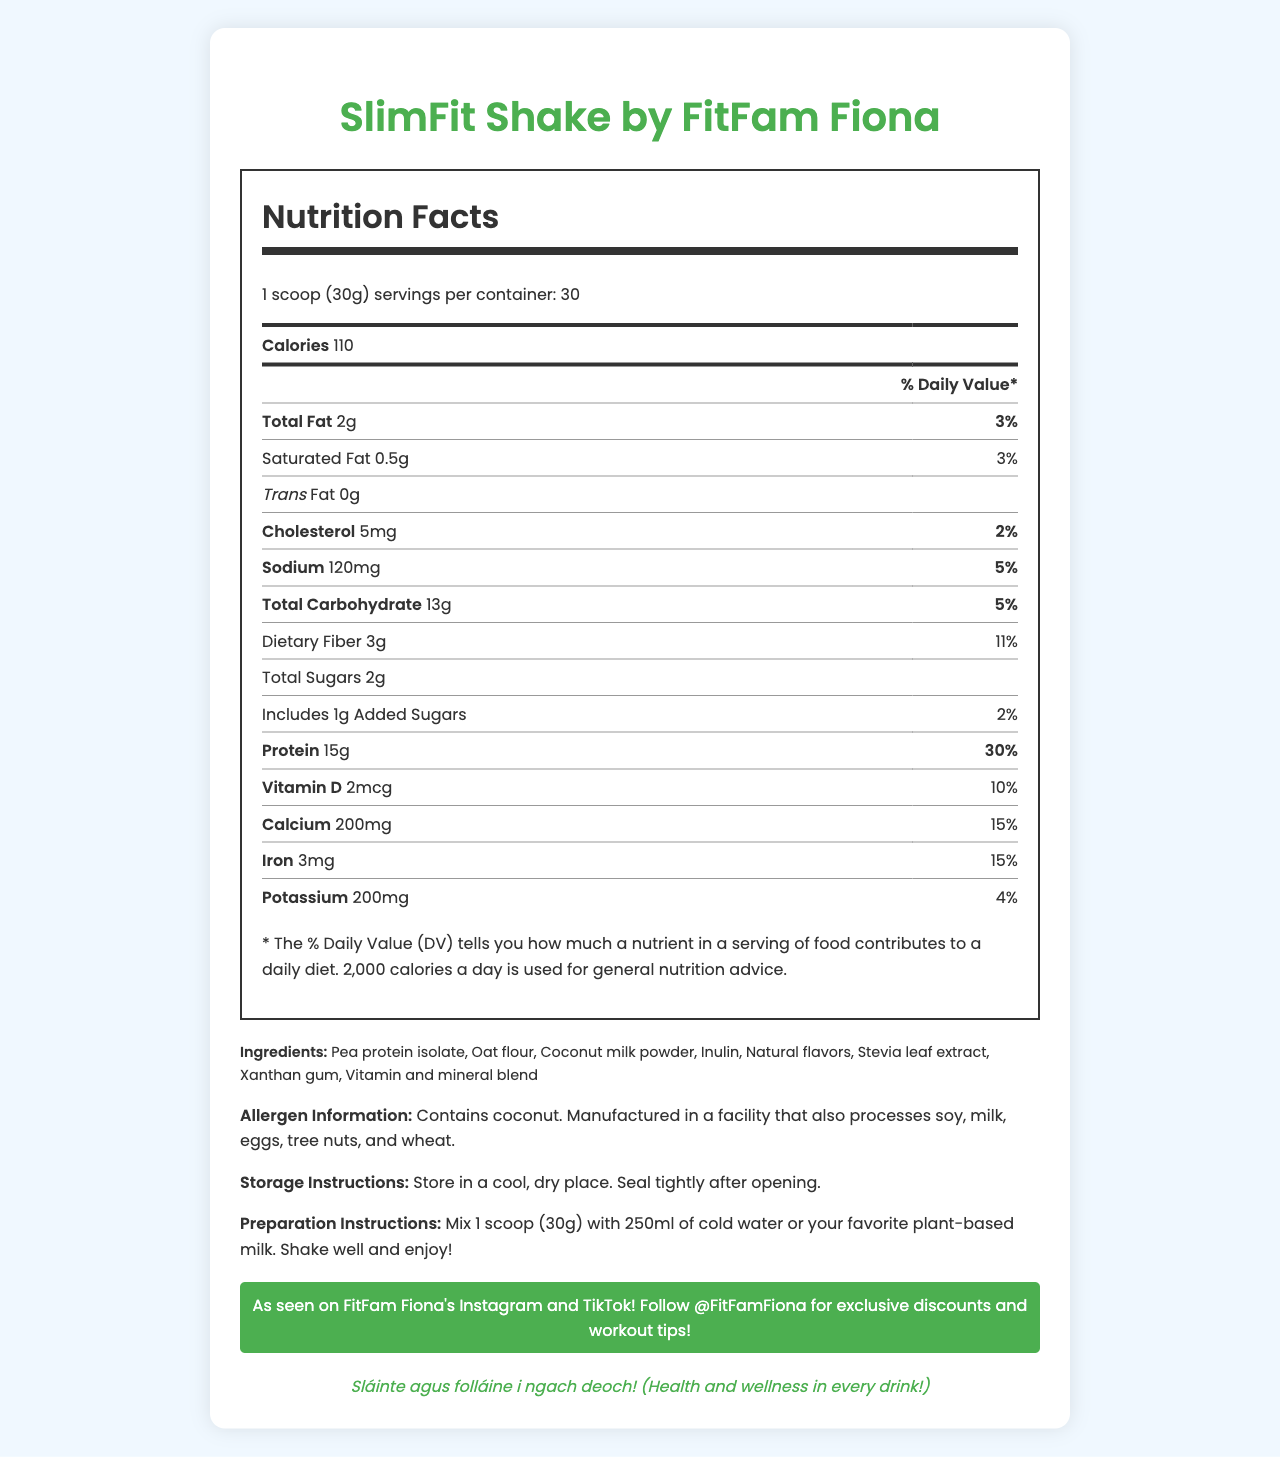what is the serving size of SlimFit Shake by FitFam Fiona? The document specifies the serving size as "1 scoop (30g)".
Answer: 1 scoop (30g) how many servings are there in a container of SlimFit Shake by FitFam Fiona? The document states that there are 30 servings per container.
Answer: 30 what is the total fat content per serving? The total fat per serving is listed as 2g.
Answer: 2g how many grams of dietary fiber are in each serving? The dietary fiber per serving is 3g as mentioned in the document.
Answer: 3g what is the suggested preparation method for SlimFit Shake by FitFam Fiona? The preparation instructions in the document elaborate on mixing 1 scoop (30g) with 250ml of cold water or plant-based milk and shaking it well.
Answer: Mix 1 scoop (30g) with 250ml of cold water or your favorite plant-based milk. Shake well and enjoy! how much cholesterol is there in one serving? A. 5mg B. 10mg C. 15mg D. 20mg The cholesterol content per serving is 5mg according to the document.
Answer: A. 5mg what is the daily value percentage of calcium in a single serving? A. 10% B. 15% C. 20% D. 25% The daily value percentage of calcium in a single serving is 15%.
Answer: B. 15% is the SlimFit Shake suitable for someone allergic to coconut? The allergen information states that the product contains coconut.
Answer: No describe the endorsement from FitFam Fiona about the SlimFit Shake. The document highlights the influencer endorsement from FitFam Fiona, promoting the product on Instagram and TikTok, along with offering exclusive discounts and workout tips.
Answer: As seen on FitFam Fiona's Instagram and TikTok! Follow @FitFamFiona for exclusive discounts and workout tips! what are the main vitamins present in the SlimFit Shake? The document lists several vitamins including Vitamin D, Calcium, Iron, Potassium, Vitamin A, Vitamin C, Vitamin E, and Vitamin B12.
Answer: Vitamin D, Calcium, Iron, Potassium, Vitamin A, Vitamin C, Vitamin E, Vitamin B12 how should the product be stored? The storage instructions advise storing the product in a cool, dry place and sealing it tightly after opening.
Answer: Store in a cool, dry place. Seal tightly after opening. what is the total carbohydrate content per serving of SlimFit Shake by FitFam Fiona? The document indicates that the total carbohydrate content per serving is 13g.
Answer: 13g what slogan is included for the Irish market? The Irish slogan included in the document is "Sláinte agus folláine i ngach deoch! (Health and wellness in every drink!)"
Answer: Sláinte agus folláine i ngach deoch! (Health and wellness in every drink!) does the SlimFit Shake contain any trans fat? The document specifies that there are 0g of trans fat per serving.
Answer: No which of the following is not listed as an ingredient in SlimFit Shake? A. Pea protein isolate B. Oat flour C. Wheat protein D. Stevia leaf extract The ingredients list includes Pea protein isolate, Oat flour, and Stevia leaf extract but does not include Wheat protein.
Answer: C. Wheat protein can you determine if the facility also processes peanuts based on the given document? The document mentions that the facility processes soy, milk, eggs, tree nuts, and wheat, but does not provide information about peanuts.
Answer: Not enough information what is the calorie content per serving? The calorie content per serving is clearly stated as 110 calories.
Answer: 110 calories what is the main focus of the SlimFit Shake by FitFam Fiona document? The main focus of the document is to present the nutritional details and related information of the SlimFit Shake, emphasizing its health benefits, and providing endorsement from FitFam Fiona.
Answer: This document provides detailed nutritional information for SlimFit Shake, a low-calorie meal replacement shake marketed by FitFam Fiona, including serving size, ingredients, allergen info, storage and preparation instructions, vitamin and mineral content, and influencer endorsement. 